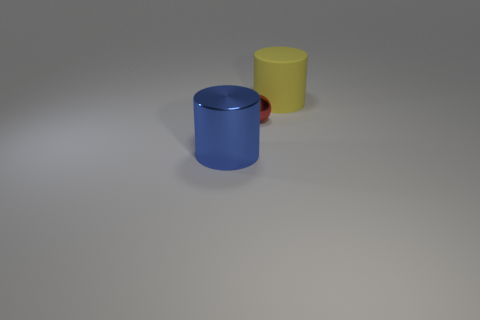There is another blue object that is the same material as the tiny object; what is its shape?
Keep it short and to the point. Cylinder. Does the cylinder in front of the yellow object have the same material as the large yellow cylinder?
Provide a succinct answer. No. There is a large cylinder that is in front of the rubber cylinder; is its color the same as the large cylinder on the right side of the blue metal object?
Make the answer very short. No. What number of big cylinders are both in front of the rubber cylinder and behind the shiny cylinder?
Provide a succinct answer. 0. What is the material of the large blue cylinder?
Offer a very short reply. Metal. What is the shape of the blue shiny object that is the same size as the yellow object?
Offer a terse response. Cylinder. Are the object that is behind the small red metallic ball and the cylinder to the left of the tiny thing made of the same material?
Give a very brief answer. No. What number of small cyan rubber cylinders are there?
Your response must be concise. 0. How many other objects are the same shape as the big metal thing?
Your response must be concise. 1. Is the shape of the tiny red thing the same as the blue shiny object?
Provide a succinct answer. No. 